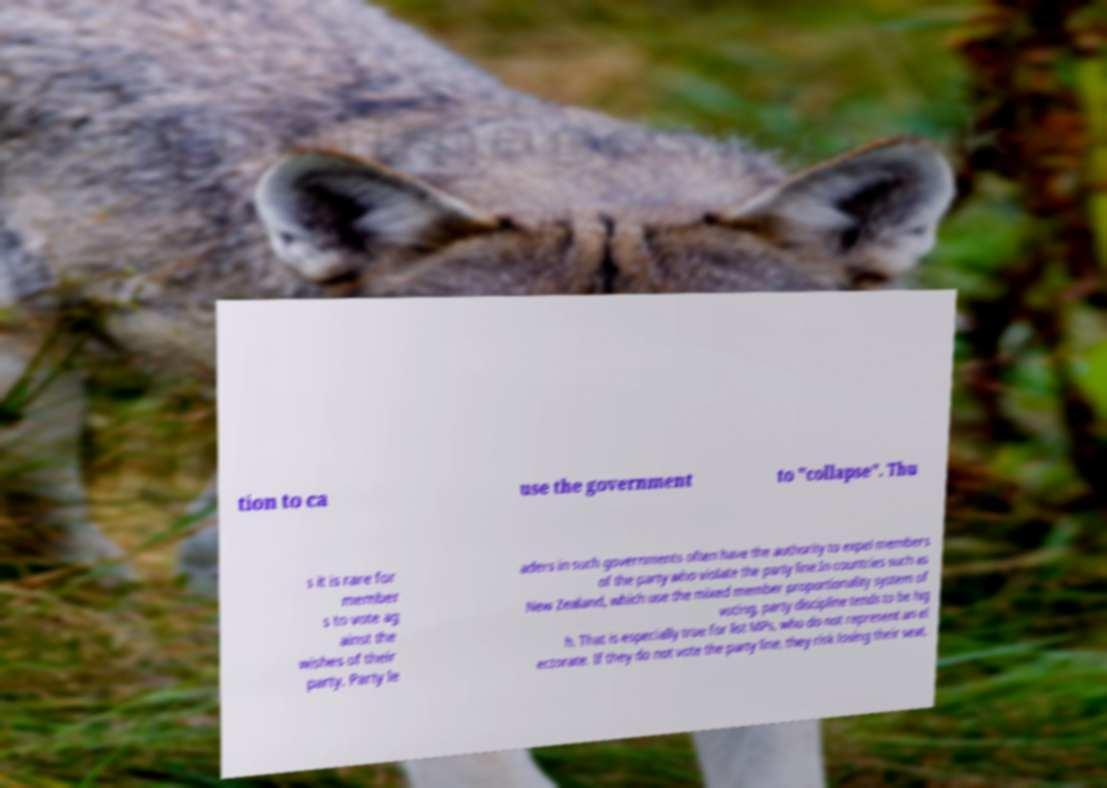Please identify and transcribe the text found in this image. tion to ca use the government to "collapse". Thu s it is rare for member s to vote ag ainst the wishes of their party. Party le aders in such governments often have the authority to expel members of the party who violate the party line.In countries such as New Zealand, which use the mixed member proportionality system of voting, party discipline tends to be hig h. That is especially true for list MPs, who do not represent an el ectorate. If they do not vote the party line, they risk losing their seat. 